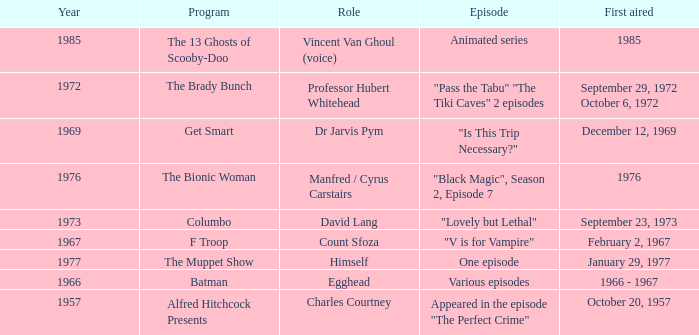What's the episode of Batman? Various episodes. 